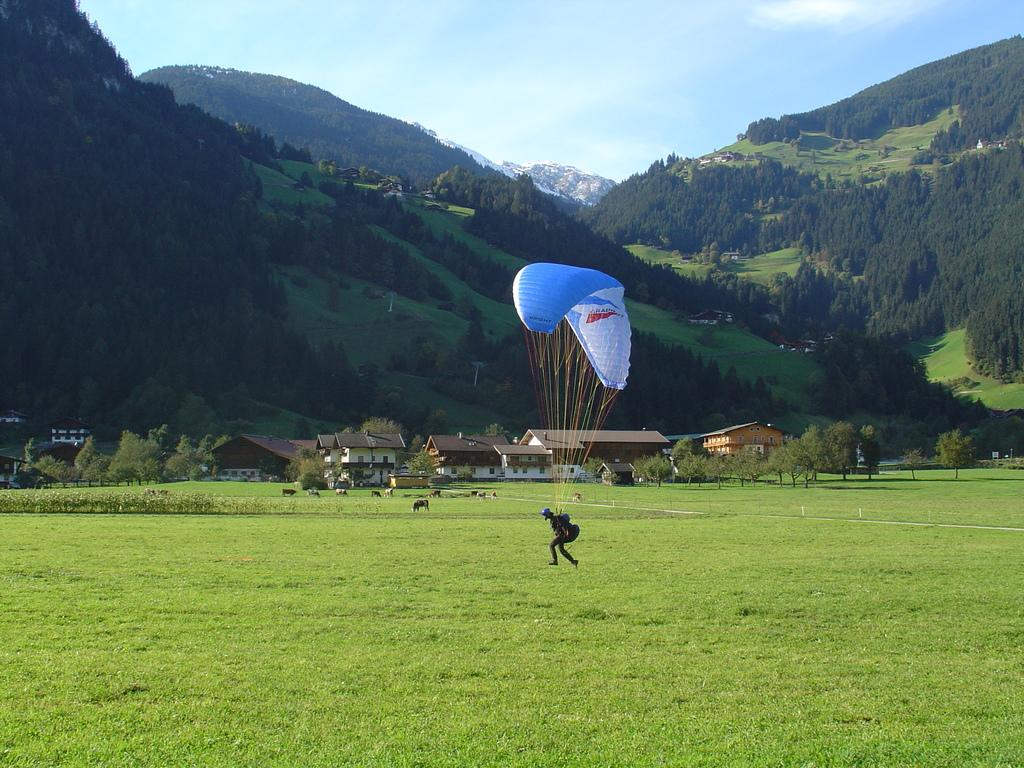What is the person in the image doing? The person is using a parachute in the image. What can be seen in the background of the image? There are buildings, trees, mountains, and the sky visible in the background of the image. What type of terrain is visible in the image? There is grass visible in the image. Are there any living creatures on the ground in the image? Yes, there are animals on the ground in the image. What type of alarm can be heard going off in the image? There is no alarm present in the image, and therefore no sound can be heard. What is the person using to cover their arm in the image? The person is using a parachute, not an object to cover their arm, in the image. 